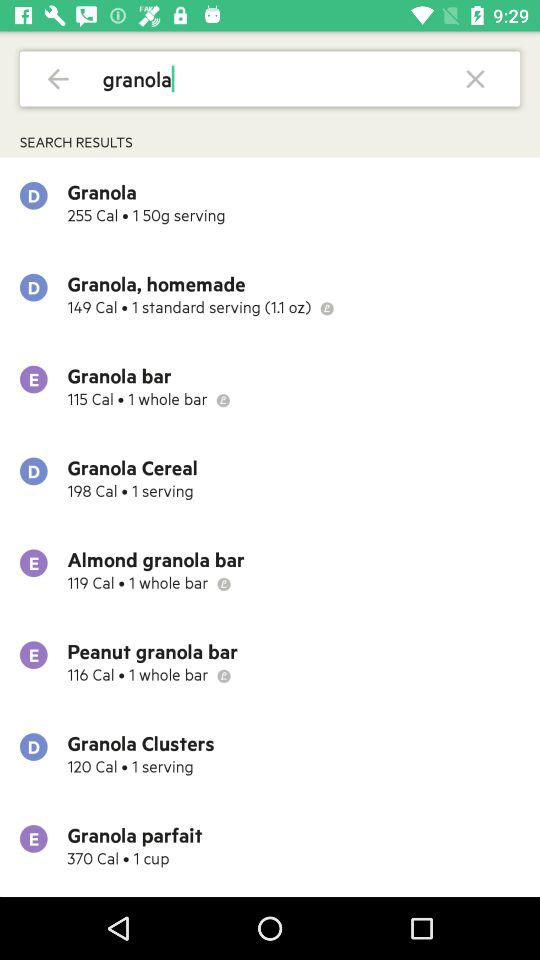Which item has the lowest calorie count, granola clusters or granola parfait?
Answer the question using a single word or phrase. Granola clusters 